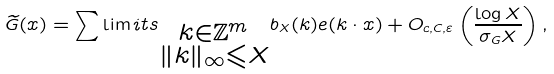Convert formula to latex. <formula><loc_0><loc_0><loc_500><loc_500>\widetilde { G } ( x ) = \sum \lim i t s _ { \substack { k \in \mathbb { Z } ^ { m } \\ \| k \| _ { \infty } \leqslant X } } b _ { X } ( k ) e ( k \cdot x ) + O _ { c , C , \varepsilon } \left ( \frac { \log X } { \sigma _ { G } X } \right ) ,</formula> 